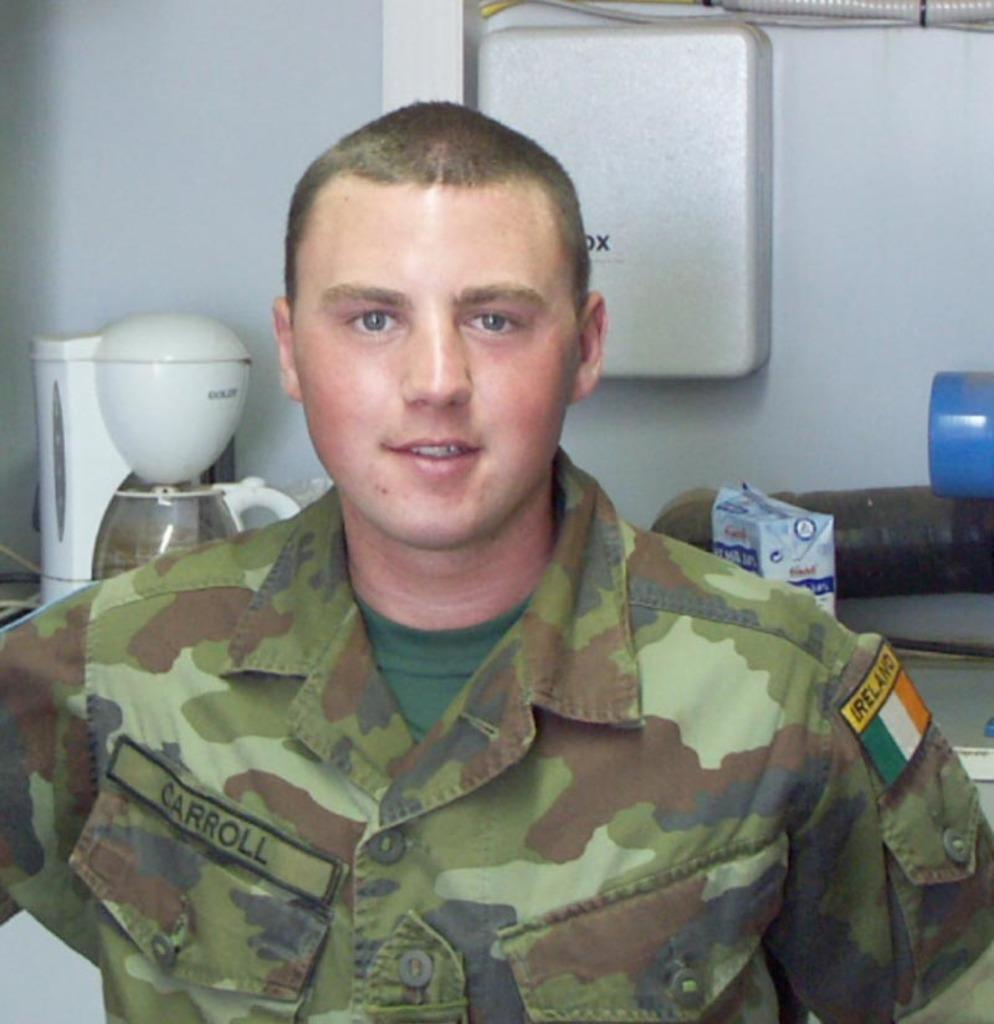<image>
Render a clear and concise summary of the photo. a person from the army wearing a carroll outfit 